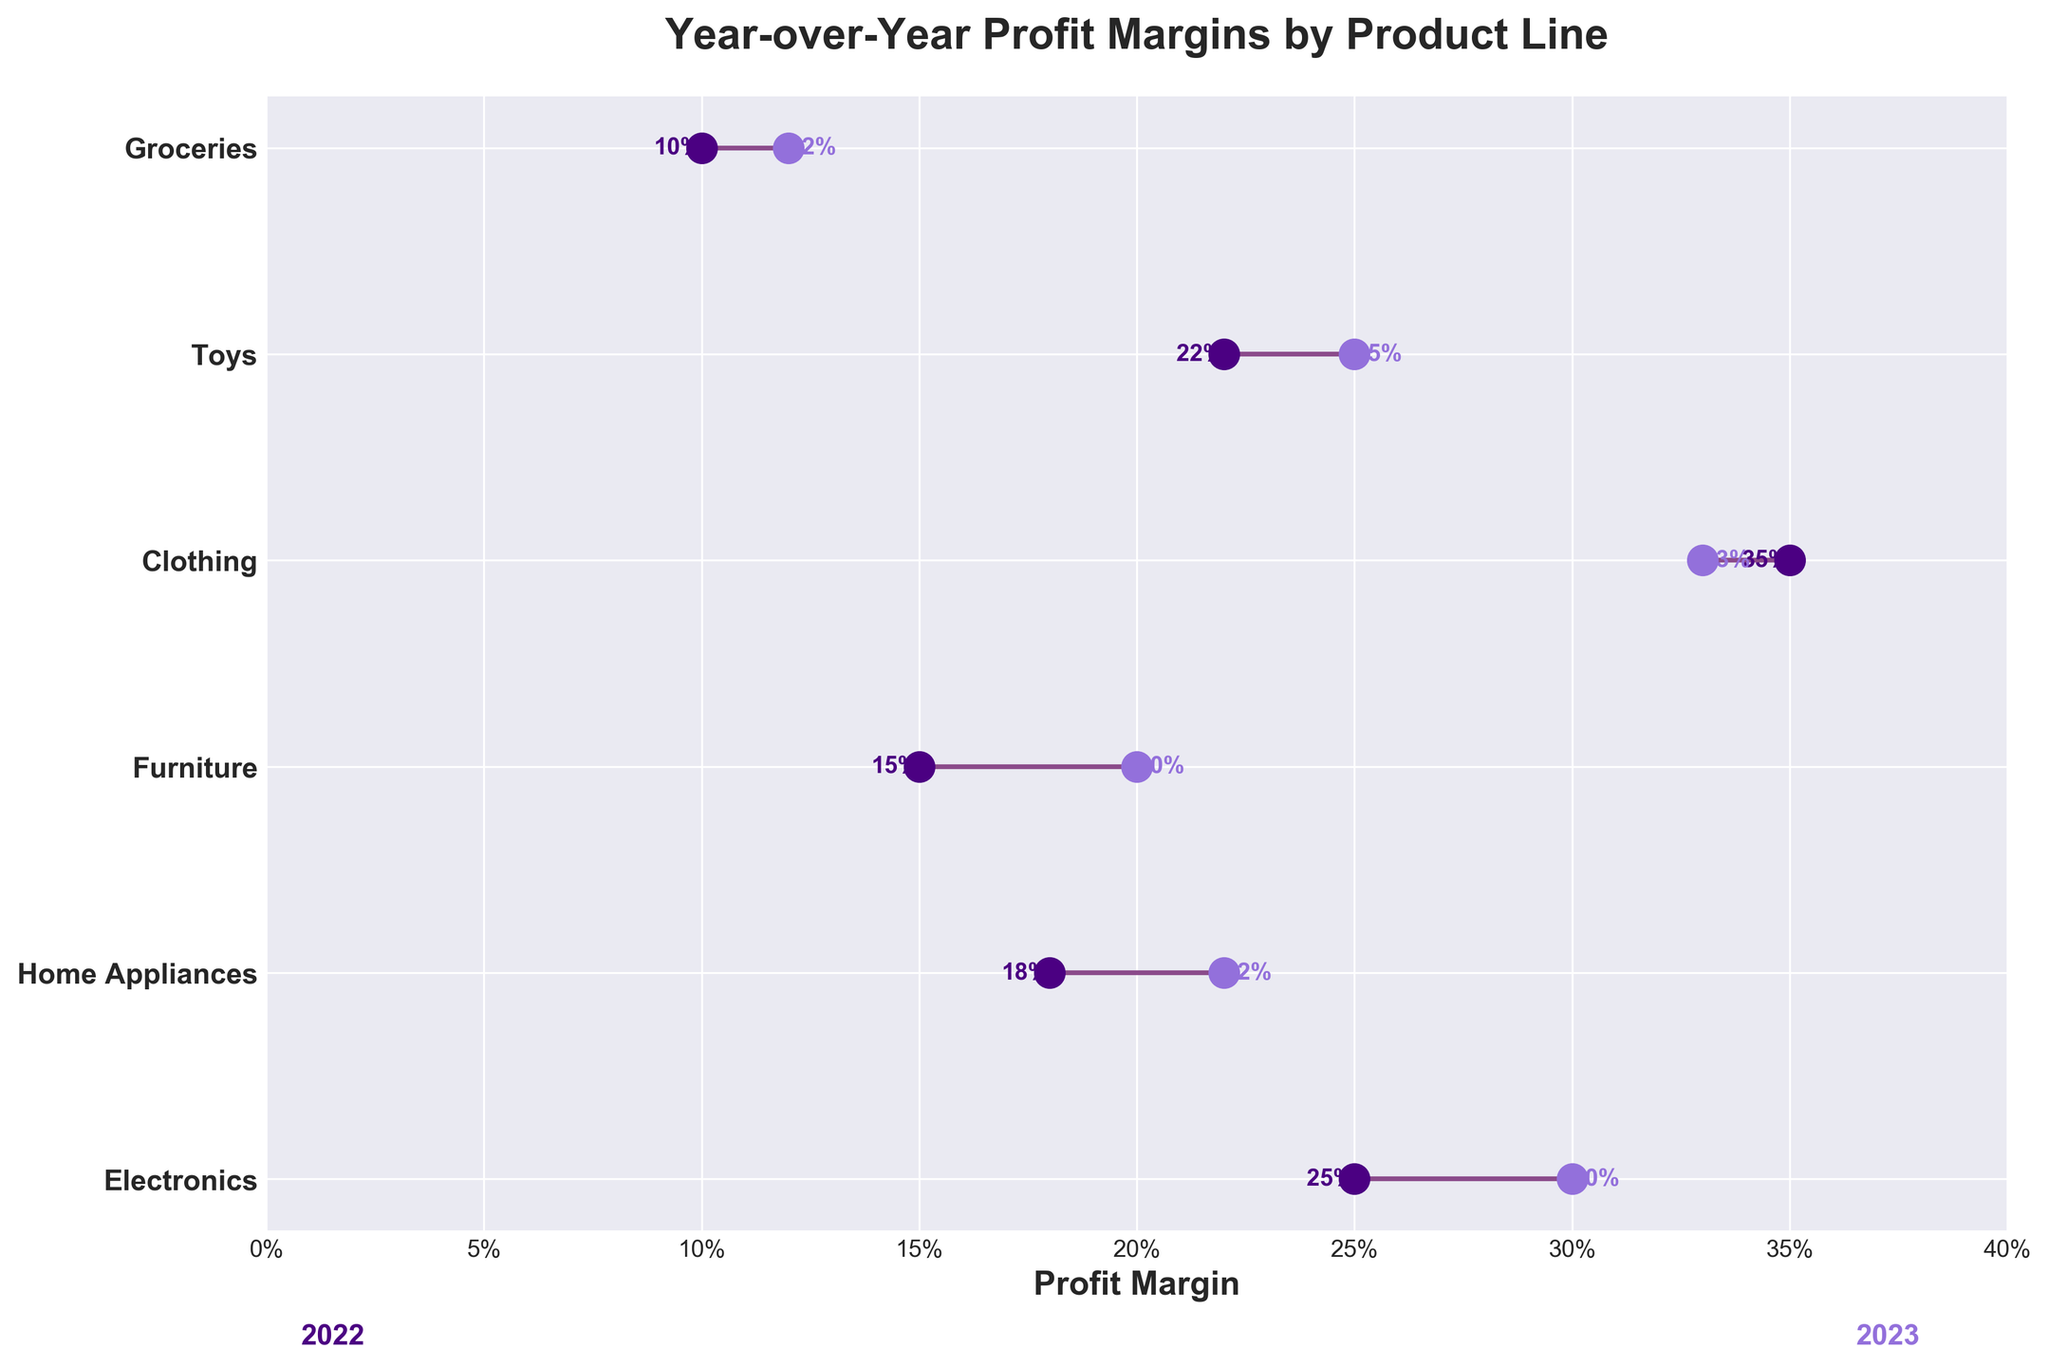what is the title of the plot? The title is usually found at the top of the plot and it provides a summary of what the plot is about. By looking at the top, you can read the title which states the main focus of the graph.
Answer: Year-over-Year Profit Margins by Product Line What are the years displayed in the plot? The years are mentioned in the text elements and the legends within the plot. By reading these elements, it's visible which years are being compared.
Answer: 2022 and 2023 Which product line has the highest profit margin in 2022? By examining the y-axis labels and following the corresponding lines to their endpoints, the highest dot on the x-axis for 2022 indicates the product line with the highest profit margin.
Answer: Clothing Did any product lines have a decrease in profit margin from 2022 to 2023? To determine this, compare the positions of the dots for each product line from 2022 to 2023. A decrease would show the 2023 dot being to the left of the 2022 dot.
Answer: Clothing What is the difference in profit margin for Electronics from 2022 to 2023? Locate the dots representing Electronics for both years. Subtract the 2022 profit margin from the 2023 profit margin to find the difference.
Answer: 0.05 (0.30 - 0.25) Which product lines have the same profit margin in 2023? Identify and compare the positions of the dots on the right side (2023) for all product lines. If two or more dots align vertically, their profit margins are the same.
Answer: None Which product line showed the greatest increase in profit margin from 2022 to 2023? Calculate the increase for each product by subtracting the 2022 margin from the 2023 margin and compare these values to find the largest one.
Answer: Furniture What is the average profit margin in 2023 across all product lines? Sum the profit margins for 2023 for all product lines and divide by the number of product lines. (0.30 + 0.22 + 0.20 + 0.33 + 0.25 + 0.12) / 6 = 1.42 / 6
Answer: 0.2367 Which product line has the lowest profit margin in 2023? Identify the point that is furthest to the left on the x-axis for the year 2023.
Answer: Groceries How is the profit margin for Home Appliances in 2022 compared to 2023? Compare the position of the Home Appliances dots from 2022 and 2023. A further right position in 2023 indicates an increase.
Answer: Increased 